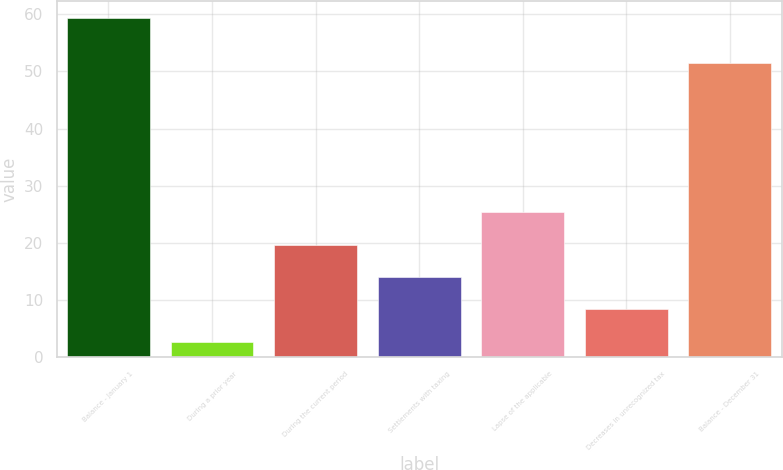<chart> <loc_0><loc_0><loc_500><loc_500><bar_chart><fcel>Balance - January 1<fcel>During a prior year<fcel>During the current period<fcel>Settlements with taxing<fcel>Lapse of the applicable<fcel>Decreases in unrecognized tax<fcel>Balance - December 31<nl><fcel>59.3<fcel>2.7<fcel>19.68<fcel>14.02<fcel>25.34<fcel>8.36<fcel>51.5<nl></chart> 